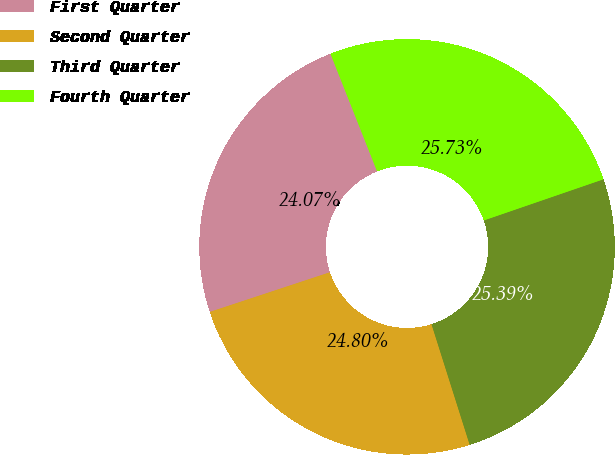<chart> <loc_0><loc_0><loc_500><loc_500><pie_chart><fcel>First Quarter<fcel>Second Quarter<fcel>Third Quarter<fcel>Fourth Quarter<nl><fcel>24.07%<fcel>24.8%<fcel>25.39%<fcel>25.73%<nl></chart> 